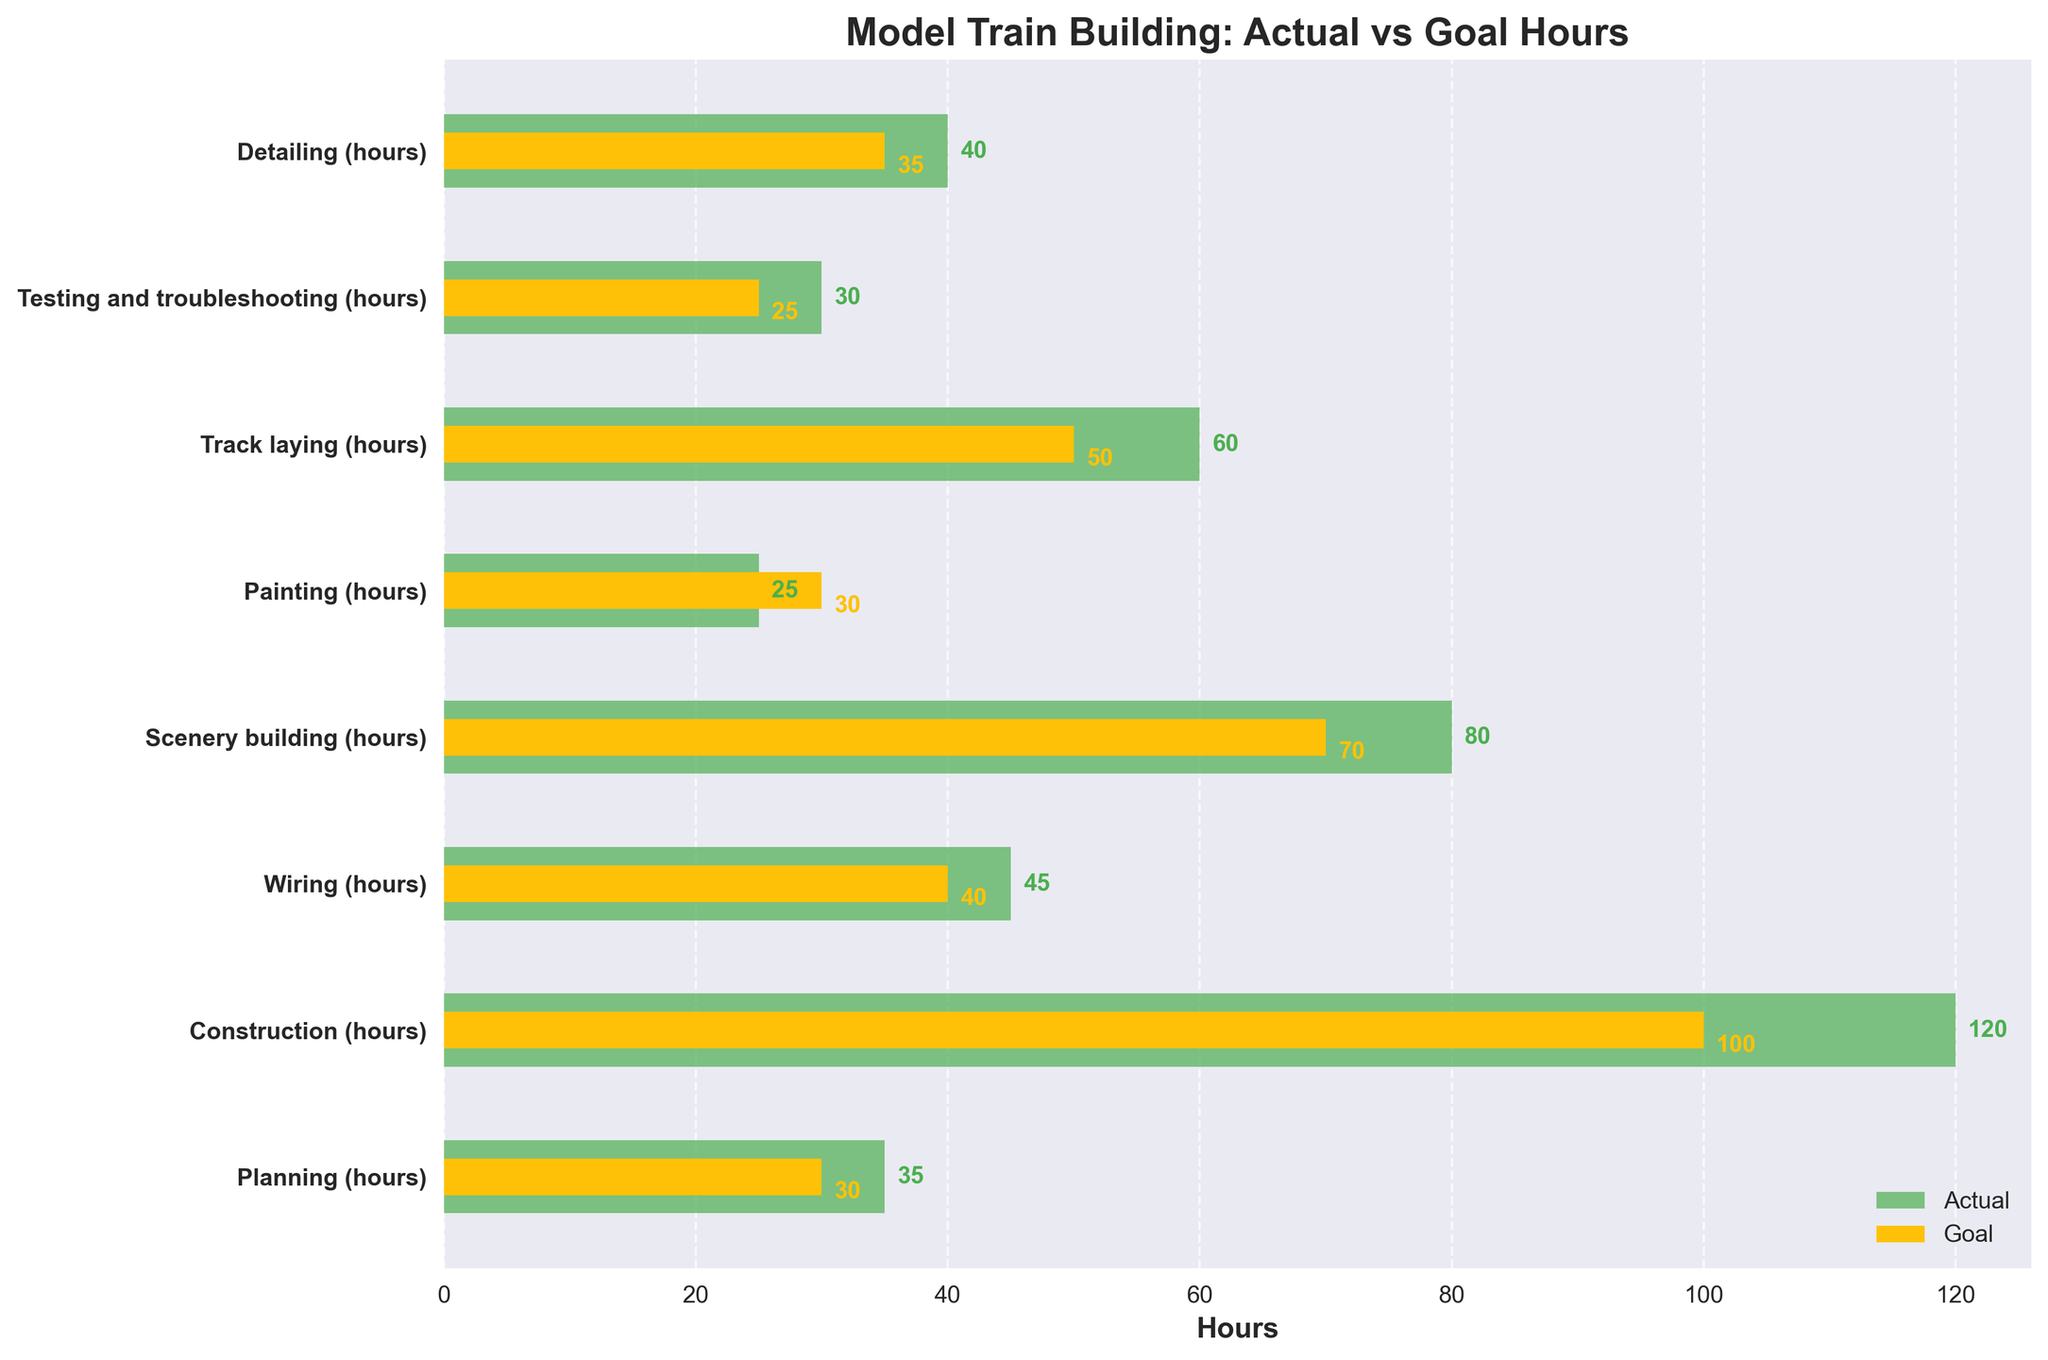How many categories are displayed in the chart? There are 8 different categories listed as "Planning (hours)", "Construction (hours)", "Wiring (hours)", "Scenery building (hours)", "Painting (hours)", "Track laying (hours)", "Testing and troubleshooting (hours)", and "Detailing (hours)".
Answer: 8 Which category has the highest actual hours? By comparing the "Actual" values across all categories, "Construction (hours)" has the highest number at 120 hours.
Answer: Construction (hours) Which category has the actual hours falling short of the goal hours? By comparing the "Actual" and "Goal" values, "Painting (hours)" has 25 actual hours, which is less than the goal of 30 hours.
Answer: Painting (hours) How much more time was spent on "Track laying (hours)" than its goal? The "Actual" time spent on "Track laying (hours)" is 60 hours, and the goal is 50 hours. The difference is 60 - 50.
Answer: 10 hours What is the total actual time spent on all categories combined? Sum up all the "Actual" hours: 35 + 120 + 45 + 80 + 25 + 60 + 30 + 40.
Answer: 435 hours Which two categories have the least difference between actual and goal hours? Calculate the differences: (Planning: 35-30=5), (Construction: 120-100=20), (Wiring: 45-40=5), (Scenery building: 80-70=10), (Painting: 25-30=-5), (Track laying: 60-50=10), (Testing and troubleshooting: 30-25=5), (Detailing: 40-35=5). "Planning (hours)" and "Wiring (hours)", "Testing and troubleshooting (hours)", "Detailing (hours)" all have a difference of 5 hours.
Answer: Planning (hours) and Wiring (hours) and Testing and troubleshooting (hours) and Detailing (hours) What is the percentage completion of the goal in "Scenery building (hours)"? The "Actual" for "Scenery building (hours)" is 80 and the "Goal" is 70. The percentage is (80/70)*100%.
Answer: 114.29% How much more time in hours was spent on "Wiring (hours)" than "Detailing (hours)" goals? The "Goal" for Wiring is 40 hours, and for Detailing is 35 hours. The difference is 40 - 35.
Answer: 5 hours Which category exceeded the goal the most? Calculate the difference for each: (Planning: 35-30=5), (Construction: 120-100=20), (Wiring: 45-40=5), (Scenery building: 80-70=10), (Painting: 25-30=-5), (Track laying: 60-50=10), (Testing and troubleshooting: 30-25=5), (Detailing: 40-35=5). "Construction" exceeded its goal by the most, 20 hours.
Answer: Construction (hours) 